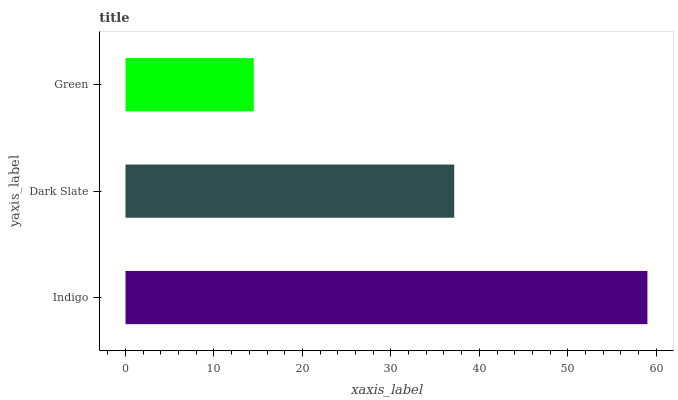Is Green the minimum?
Answer yes or no. Yes. Is Indigo the maximum?
Answer yes or no. Yes. Is Dark Slate the minimum?
Answer yes or no. No. Is Dark Slate the maximum?
Answer yes or no. No. Is Indigo greater than Dark Slate?
Answer yes or no. Yes. Is Dark Slate less than Indigo?
Answer yes or no. Yes. Is Dark Slate greater than Indigo?
Answer yes or no. No. Is Indigo less than Dark Slate?
Answer yes or no. No. Is Dark Slate the high median?
Answer yes or no. Yes. Is Dark Slate the low median?
Answer yes or no. Yes. Is Green the high median?
Answer yes or no. No. Is Indigo the low median?
Answer yes or no. No. 